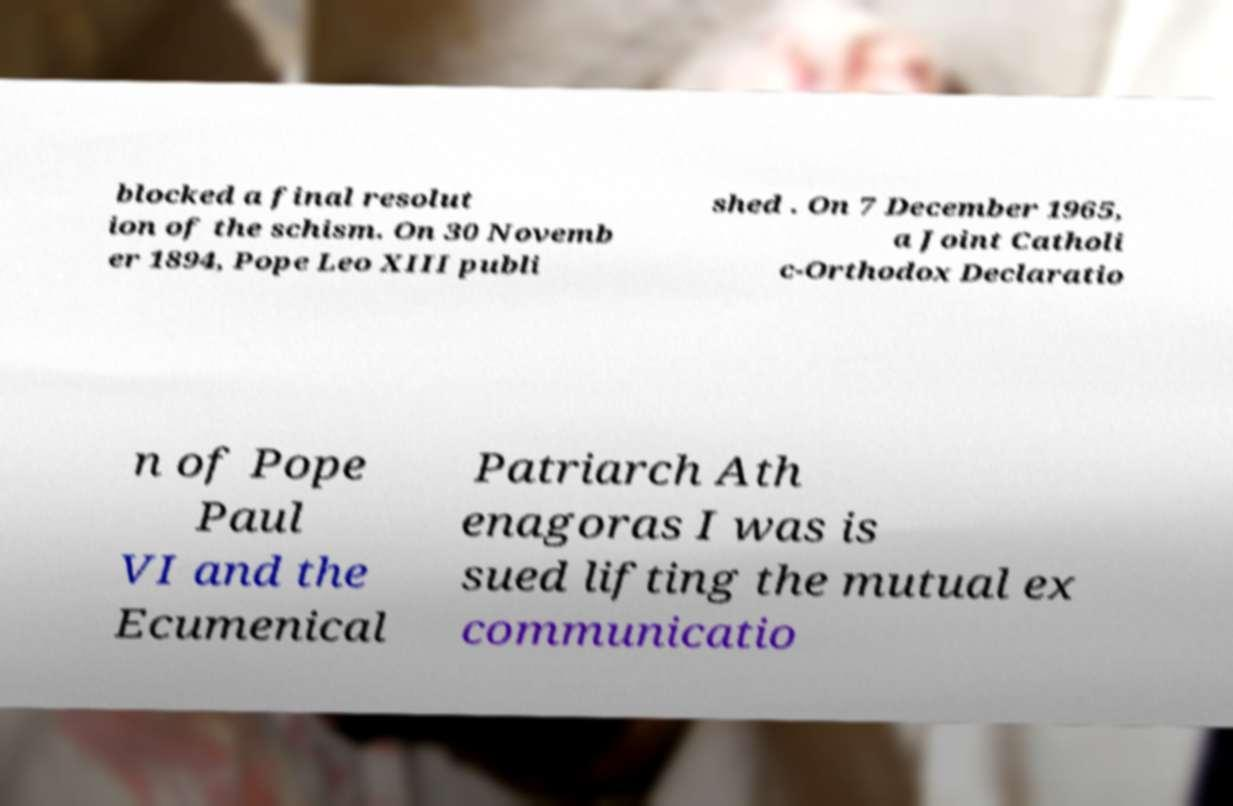Please read and relay the text visible in this image. What does it say? blocked a final resolut ion of the schism. On 30 Novemb er 1894, Pope Leo XIII publi shed . On 7 December 1965, a Joint Catholi c-Orthodox Declaratio n of Pope Paul VI and the Ecumenical Patriarch Ath enagoras I was is sued lifting the mutual ex communicatio 